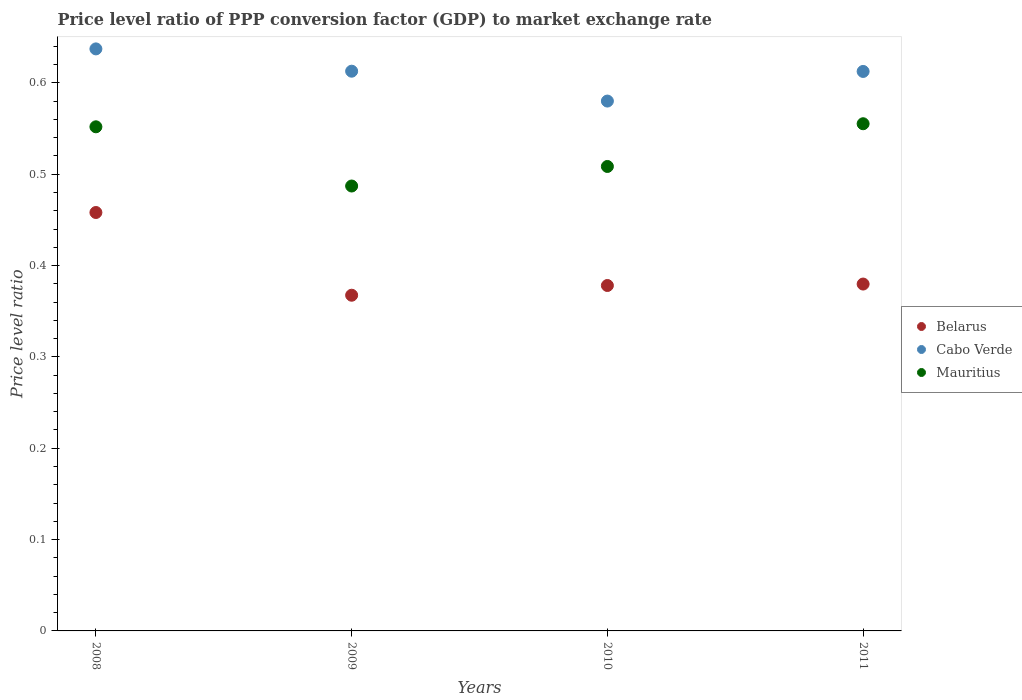How many different coloured dotlines are there?
Keep it short and to the point. 3. What is the price level ratio in Belarus in 2009?
Keep it short and to the point. 0.37. Across all years, what is the maximum price level ratio in Mauritius?
Provide a succinct answer. 0.56. Across all years, what is the minimum price level ratio in Mauritius?
Keep it short and to the point. 0.49. In which year was the price level ratio in Cabo Verde minimum?
Make the answer very short. 2010. What is the total price level ratio in Cabo Verde in the graph?
Your answer should be very brief. 2.44. What is the difference between the price level ratio in Cabo Verde in 2008 and that in 2009?
Your response must be concise. 0.02. What is the difference between the price level ratio in Cabo Verde in 2011 and the price level ratio in Belarus in 2009?
Keep it short and to the point. 0.25. What is the average price level ratio in Mauritius per year?
Your answer should be very brief. 0.53. In the year 2009, what is the difference between the price level ratio in Cabo Verde and price level ratio in Belarus?
Ensure brevity in your answer.  0.25. What is the ratio of the price level ratio in Belarus in 2008 to that in 2009?
Ensure brevity in your answer.  1.25. What is the difference between the highest and the second highest price level ratio in Cabo Verde?
Offer a very short reply. 0.02. What is the difference between the highest and the lowest price level ratio in Cabo Verde?
Keep it short and to the point. 0.06. Is the sum of the price level ratio in Mauritius in 2009 and 2010 greater than the maximum price level ratio in Belarus across all years?
Keep it short and to the point. Yes. Is it the case that in every year, the sum of the price level ratio in Belarus and price level ratio in Cabo Verde  is greater than the price level ratio in Mauritius?
Offer a very short reply. Yes. Is the price level ratio in Mauritius strictly greater than the price level ratio in Cabo Verde over the years?
Your answer should be very brief. No. Is the price level ratio in Cabo Verde strictly less than the price level ratio in Belarus over the years?
Keep it short and to the point. No. How many years are there in the graph?
Your answer should be compact. 4. What is the difference between two consecutive major ticks on the Y-axis?
Offer a terse response. 0.1. Does the graph contain grids?
Your answer should be very brief. No. What is the title of the graph?
Provide a short and direct response. Price level ratio of PPP conversion factor (GDP) to market exchange rate. Does "Canada" appear as one of the legend labels in the graph?
Give a very brief answer. No. What is the label or title of the Y-axis?
Offer a very short reply. Price level ratio. What is the Price level ratio in Belarus in 2008?
Offer a terse response. 0.46. What is the Price level ratio of Cabo Verde in 2008?
Your answer should be very brief. 0.64. What is the Price level ratio of Mauritius in 2008?
Offer a very short reply. 0.55. What is the Price level ratio of Belarus in 2009?
Your response must be concise. 0.37. What is the Price level ratio in Cabo Verde in 2009?
Provide a succinct answer. 0.61. What is the Price level ratio of Mauritius in 2009?
Provide a short and direct response. 0.49. What is the Price level ratio of Belarus in 2010?
Keep it short and to the point. 0.38. What is the Price level ratio of Cabo Verde in 2010?
Your answer should be very brief. 0.58. What is the Price level ratio of Mauritius in 2010?
Offer a very short reply. 0.51. What is the Price level ratio of Belarus in 2011?
Offer a terse response. 0.38. What is the Price level ratio in Cabo Verde in 2011?
Provide a short and direct response. 0.61. What is the Price level ratio in Mauritius in 2011?
Offer a very short reply. 0.56. Across all years, what is the maximum Price level ratio in Belarus?
Your answer should be very brief. 0.46. Across all years, what is the maximum Price level ratio of Cabo Verde?
Make the answer very short. 0.64. Across all years, what is the maximum Price level ratio of Mauritius?
Keep it short and to the point. 0.56. Across all years, what is the minimum Price level ratio of Belarus?
Keep it short and to the point. 0.37. Across all years, what is the minimum Price level ratio in Cabo Verde?
Provide a succinct answer. 0.58. Across all years, what is the minimum Price level ratio in Mauritius?
Your response must be concise. 0.49. What is the total Price level ratio of Belarus in the graph?
Your answer should be very brief. 1.58. What is the total Price level ratio of Cabo Verde in the graph?
Offer a very short reply. 2.44. What is the total Price level ratio of Mauritius in the graph?
Provide a succinct answer. 2.1. What is the difference between the Price level ratio of Belarus in 2008 and that in 2009?
Offer a terse response. 0.09. What is the difference between the Price level ratio of Cabo Verde in 2008 and that in 2009?
Your answer should be very brief. 0.02. What is the difference between the Price level ratio in Mauritius in 2008 and that in 2009?
Ensure brevity in your answer.  0.06. What is the difference between the Price level ratio of Belarus in 2008 and that in 2010?
Your answer should be compact. 0.08. What is the difference between the Price level ratio in Cabo Verde in 2008 and that in 2010?
Make the answer very short. 0.06. What is the difference between the Price level ratio of Mauritius in 2008 and that in 2010?
Give a very brief answer. 0.04. What is the difference between the Price level ratio of Belarus in 2008 and that in 2011?
Provide a succinct answer. 0.08. What is the difference between the Price level ratio of Cabo Verde in 2008 and that in 2011?
Make the answer very short. 0.02. What is the difference between the Price level ratio of Mauritius in 2008 and that in 2011?
Ensure brevity in your answer.  -0. What is the difference between the Price level ratio of Belarus in 2009 and that in 2010?
Provide a succinct answer. -0.01. What is the difference between the Price level ratio in Cabo Verde in 2009 and that in 2010?
Offer a very short reply. 0.03. What is the difference between the Price level ratio in Mauritius in 2009 and that in 2010?
Offer a very short reply. -0.02. What is the difference between the Price level ratio in Belarus in 2009 and that in 2011?
Your response must be concise. -0.01. What is the difference between the Price level ratio in Cabo Verde in 2009 and that in 2011?
Your response must be concise. 0. What is the difference between the Price level ratio of Mauritius in 2009 and that in 2011?
Offer a very short reply. -0.07. What is the difference between the Price level ratio in Belarus in 2010 and that in 2011?
Keep it short and to the point. -0. What is the difference between the Price level ratio of Cabo Verde in 2010 and that in 2011?
Your response must be concise. -0.03. What is the difference between the Price level ratio of Mauritius in 2010 and that in 2011?
Provide a succinct answer. -0.05. What is the difference between the Price level ratio in Belarus in 2008 and the Price level ratio in Cabo Verde in 2009?
Your response must be concise. -0.15. What is the difference between the Price level ratio of Belarus in 2008 and the Price level ratio of Mauritius in 2009?
Offer a very short reply. -0.03. What is the difference between the Price level ratio in Cabo Verde in 2008 and the Price level ratio in Mauritius in 2009?
Keep it short and to the point. 0.15. What is the difference between the Price level ratio of Belarus in 2008 and the Price level ratio of Cabo Verde in 2010?
Give a very brief answer. -0.12. What is the difference between the Price level ratio in Belarus in 2008 and the Price level ratio in Mauritius in 2010?
Offer a very short reply. -0.05. What is the difference between the Price level ratio in Cabo Verde in 2008 and the Price level ratio in Mauritius in 2010?
Offer a terse response. 0.13. What is the difference between the Price level ratio of Belarus in 2008 and the Price level ratio of Cabo Verde in 2011?
Your answer should be very brief. -0.15. What is the difference between the Price level ratio in Belarus in 2008 and the Price level ratio in Mauritius in 2011?
Ensure brevity in your answer.  -0.1. What is the difference between the Price level ratio in Cabo Verde in 2008 and the Price level ratio in Mauritius in 2011?
Your response must be concise. 0.08. What is the difference between the Price level ratio in Belarus in 2009 and the Price level ratio in Cabo Verde in 2010?
Your answer should be compact. -0.21. What is the difference between the Price level ratio in Belarus in 2009 and the Price level ratio in Mauritius in 2010?
Your response must be concise. -0.14. What is the difference between the Price level ratio of Cabo Verde in 2009 and the Price level ratio of Mauritius in 2010?
Your response must be concise. 0.1. What is the difference between the Price level ratio of Belarus in 2009 and the Price level ratio of Cabo Verde in 2011?
Your response must be concise. -0.24. What is the difference between the Price level ratio of Belarus in 2009 and the Price level ratio of Mauritius in 2011?
Offer a very short reply. -0.19. What is the difference between the Price level ratio of Cabo Verde in 2009 and the Price level ratio of Mauritius in 2011?
Give a very brief answer. 0.06. What is the difference between the Price level ratio in Belarus in 2010 and the Price level ratio in Cabo Verde in 2011?
Keep it short and to the point. -0.23. What is the difference between the Price level ratio of Belarus in 2010 and the Price level ratio of Mauritius in 2011?
Offer a very short reply. -0.18. What is the difference between the Price level ratio of Cabo Verde in 2010 and the Price level ratio of Mauritius in 2011?
Ensure brevity in your answer.  0.02. What is the average Price level ratio in Belarus per year?
Offer a very short reply. 0.4. What is the average Price level ratio of Cabo Verde per year?
Provide a succinct answer. 0.61. What is the average Price level ratio in Mauritius per year?
Your response must be concise. 0.53. In the year 2008, what is the difference between the Price level ratio of Belarus and Price level ratio of Cabo Verde?
Make the answer very short. -0.18. In the year 2008, what is the difference between the Price level ratio in Belarus and Price level ratio in Mauritius?
Your answer should be compact. -0.09. In the year 2008, what is the difference between the Price level ratio in Cabo Verde and Price level ratio in Mauritius?
Provide a succinct answer. 0.09. In the year 2009, what is the difference between the Price level ratio in Belarus and Price level ratio in Cabo Verde?
Keep it short and to the point. -0.25. In the year 2009, what is the difference between the Price level ratio of Belarus and Price level ratio of Mauritius?
Make the answer very short. -0.12. In the year 2009, what is the difference between the Price level ratio in Cabo Verde and Price level ratio in Mauritius?
Provide a short and direct response. 0.13. In the year 2010, what is the difference between the Price level ratio in Belarus and Price level ratio in Cabo Verde?
Offer a very short reply. -0.2. In the year 2010, what is the difference between the Price level ratio of Belarus and Price level ratio of Mauritius?
Make the answer very short. -0.13. In the year 2010, what is the difference between the Price level ratio in Cabo Verde and Price level ratio in Mauritius?
Keep it short and to the point. 0.07. In the year 2011, what is the difference between the Price level ratio in Belarus and Price level ratio in Cabo Verde?
Provide a succinct answer. -0.23. In the year 2011, what is the difference between the Price level ratio of Belarus and Price level ratio of Mauritius?
Offer a terse response. -0.18. In the year 2011, what is the difference between the Price level ratio of Cabo Verde and Price level ratio of Mauritius?
Give a very brief answer. 0.06. What is the ratio of the Price level ratio of Belarus in 2008 to that in 2009?
Your answer should be very brief. 1.25. What is the ratio of the Price level ratio of Cabo Verde in 2008 to that in 2009?
Provide a short and direct response. 1.04. What is the ratio of the Price level ratio in Mauritius in 2008 to that in 2009?
Offer a terse response. 1.13. What is the ratio of the Price level ratio of Belarus in 2008 to that in 2010?
Keep it short and to the point. 1.21. What is the ratio of the Price level ratio in Cabo Verde in 2008 to that in 2010?
Offer a terse response. 1.1. What is the ratio of the Price level ratio in Mauritius in 2008 to that in 2010?
Your answer should be very brief. 1.09. What is the ratio of the Price level ratio in Belarus in 2008 to that in 2011?
Make the answer very short. 1.21. What is the ratio of the Price level ratio of Cabo Verde in 2008 to that in 2011?
Offer a very short reply. 1.04. What is the ratio of the Price level ratio in Belarus in 2009 to that in 2010?
Offer a terse response. 0.97. What is the ratio of the Price level ratio in Cabo Verde in 2009 to that in 2010?
Make the answer very short. 1.06. What is the ratio of the Price level ratio of Mauritius in 2009 to that in 2010?
Ensure brevity in your answer.  0.96. What is the ratio of the Price level ratio in Belarus in 2009 to that in 2011?
Offer a terse response. 0.97. What is the ratio of the Price level ratio in Mauritius in 2009 to that in 2011?
Ensure brevity in your answer.  0.88. What is the ratio of the Price level ratio of Cabo Verde in 2010 to that in 2011?
Your answer should be compact. 0.95. What is the ratio of the Price level ratio of Mauritius in 2010 to that in 2011?
Provide a short and direct response. 0.92. What is the difference between the highest and the second highest Price level ratio in Belarus?
Keep it short and to the point. 0.08. What is the difference between the highest and the second highest Price level ratio of Cabo Verde?
Keep it short and to the point. 0.02. What is the difference between the highest and the second highest Price level ratio in Mauritius?
Ensure brevity in your answer.  0. What is the difference between the highest and the lowest Price level ratio of Belarus?
Offer a very short reply. 0.09. What is the difference between the highest and the lowest Price level ratio of Cabo Verde?
Ensure brevity in your answer.  0.06. What is the difference between the highest and the lowest Price level ratio in Mauritius?
Provide a short and direct response. 0.07. 